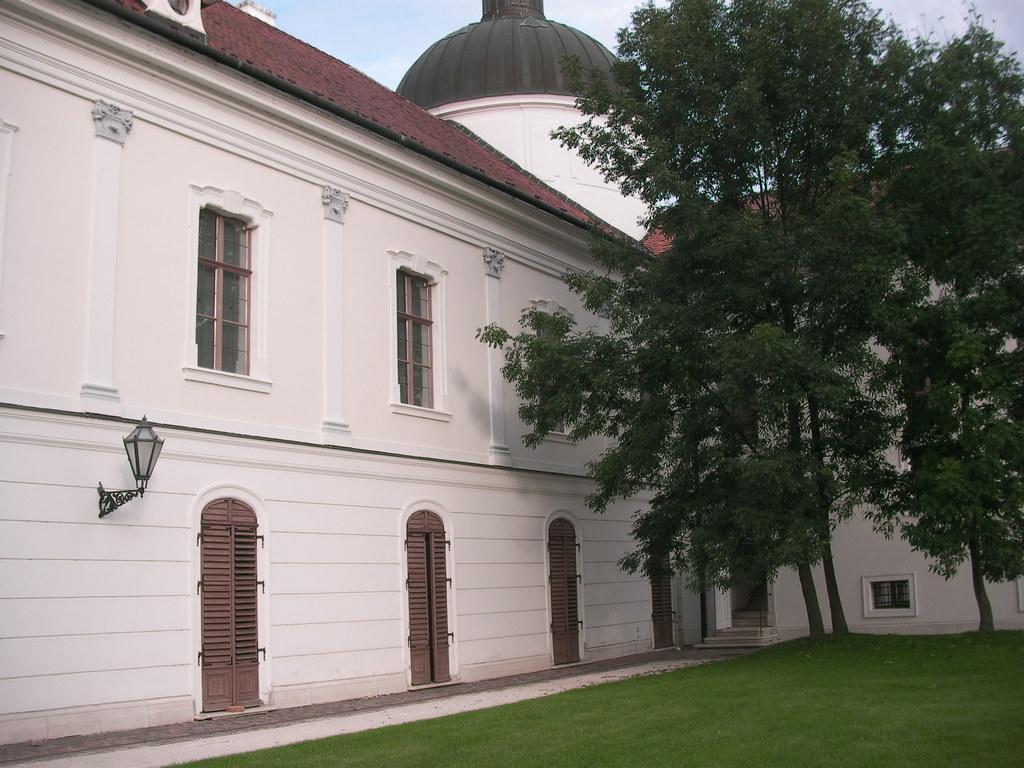What type of vegetation is present in the image? There is grass in the image. What else can be seen in the image besides grass? There are trees, buildings, and doors visible in the image. Can you describe the lighting in the image? There is light in the image. What is visible in the background of the image? The sky is visible in the background of the image. What type of weather can be seen in the image? The provided facts do not mention any specific weather conditions, so it cannot be determined from the image. Can you tell me how many matches are present in the image? There are no matches present in the image. 